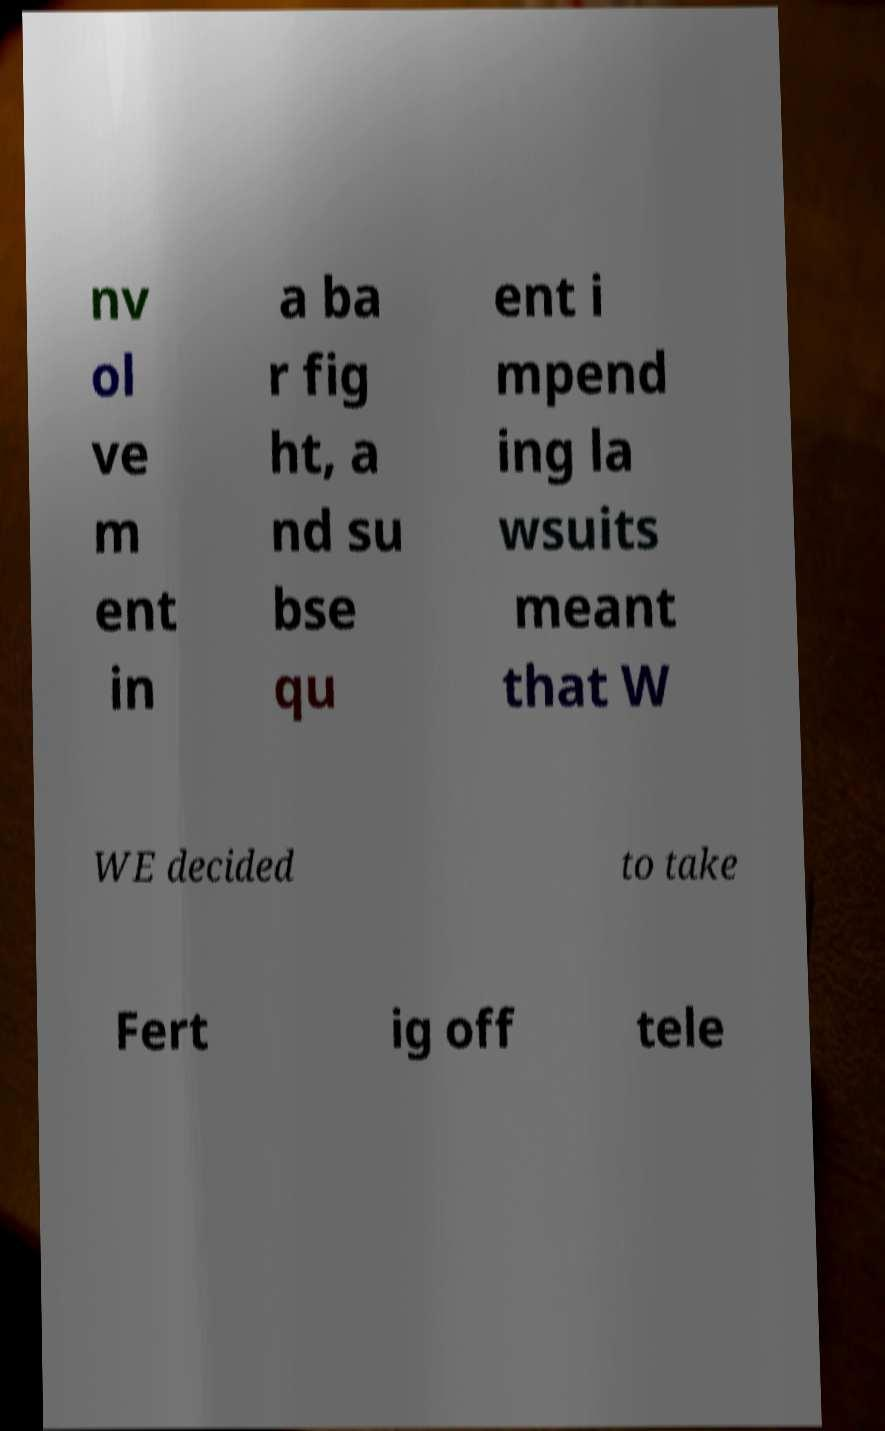Could you assist in decoding the text presented in this image and type it out clearly? nv ol ve m ent in a ba r fig ht, a nd su bse qu ent i mpend ing la wsuits meant that W WE decided to take Fert ig off tele 